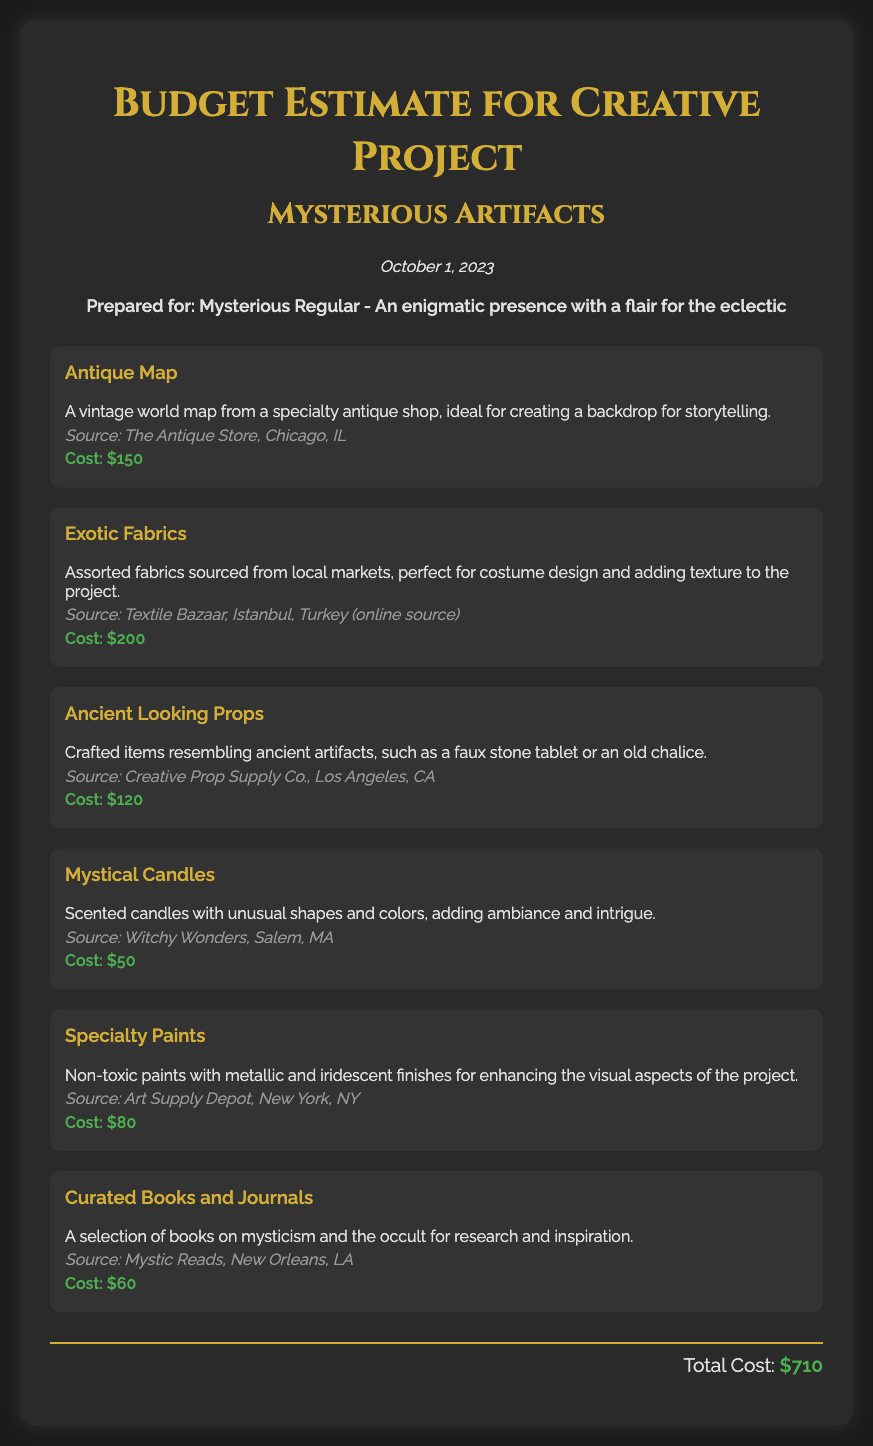What is the total cost of the budget? The total cost is found at the end of the document, summarizing all expenses to $710.
Answer: $710 What is the source of the Antique Map? Each item lists its source, with the Antique Map sourced from The Antique Store, Chicago, IL.
Answer: The Antique Store, Chicago, IL How much does the Exotic Fabrics cost? The cost listed for Exotic Fabrics is explicitly mentioned in the document, which is $200.
Answer: $200 What type of items are included under Ancient Looking Props? This description specifies crafted items such as a faux stone tablet or an old chalice, indicating their nature.
Answer: faux stone tablet or an old chalice Where are the Mystical Candles sourced from? The source of Mystical Candles is provided, which is Witchy Wonders, Salem, MA.
Answer: Witchy Wonders, Salem, MA What are the Specialty Paints used for? The document describes their use as enhancing visual aspects with metallic and iridescent finishes.
Answer: enhancing the visual aspects How many items are listed in the budget? The total number of items can be counted within the document, resulting in six distinct items.
Answer: six What date is the budget prepared on? The date of preparation is displayed prominently in the document, noted as October 1, 2023.
Answer: October 1, 2023 Who is the budget prepared for? The persona section explicitly states that the budget is prepared for Mysterious Regular.
Answer: Mysterious Regular 